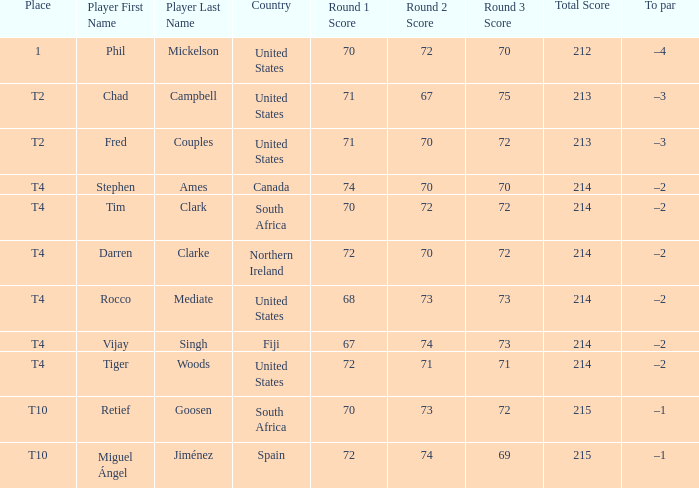What was spain's score? 72-74-69=215. 